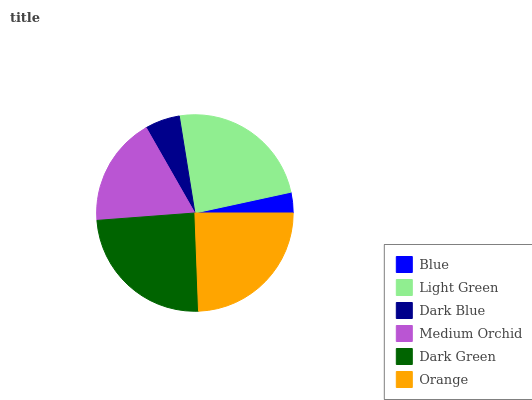Is Blue the minimum?
Answer yes or no. Yes. Is Orange the maximum?
Answer yes or no. Yes. Is Light Green the minimum?
Answer yes or no. No. Is Light Green the maximum?
Answer yes or no. No. Is Light Green greater than Blue?
Answer yes or no. Yes. Is Blue less than Light Green?
Answer yes or no. Yes. Is Blue greater than Light Green?
Answer yes or no. No. Is Light Green less than Blue?
Answer yes or no. No. Is Light Green the high median?
Answer yes or no. Yes. Is Medium Orchid the low median?
Answer yes or no. Yes. Is Dark Green the high median?
Answer yes or no. No. Is Dark Blue the low median?
Answer yes or no. No. 